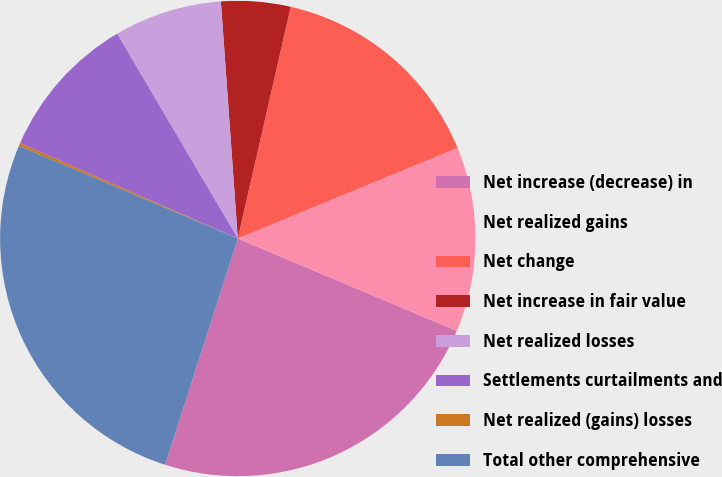Convert chart to OTSL. <chart><loc_0><loc_0><loc_500><loc_500><pie_chart><fcel>Net increase (decrease) in<fcel>Net realized gains<fcel>Net change<fcel>Net increase in fair value<fcel>Net realized losses<fcel>Settlements curtailments and<fcel>Net realized (gains) losses<fcel>Total other comprehensive<nl><fcel>23.59%<fcel>12.58%<fcel>15.2%<fcel>4.71%<fcel>7.34%<fcel>9.96%<fcel>0.2%<fcel>26.42%<nl></chart> 